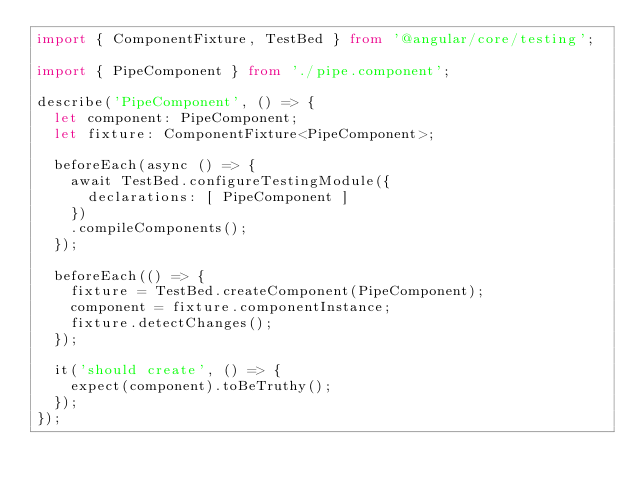<code> <loc_0><loc_0><loc_500><loc_500><_TypeScript_>import { ComponentFixture, TestBed } from '@angular/core/testing';

import { PipeComponent } from './pipe.component';

describe('PipeComponent', () => {
  let component: PipeComponent;
  let fixture: ComponentFixture<PipeComponent>;

  beforeEach(async () => {
    await TestBed.configureTestingModule({
      declarations: [ PipeComponent ]
    })
    .compileComponents();
  });

  beforeEach(() => {
    fixture = TestBed.createComponent(PipeComponent);
    component = fixture.componentInstance;
    fixture.detectChanges();
  });

  it('should create', () => {
    expect(component).toBeTruthy();
  });
});
</code> 